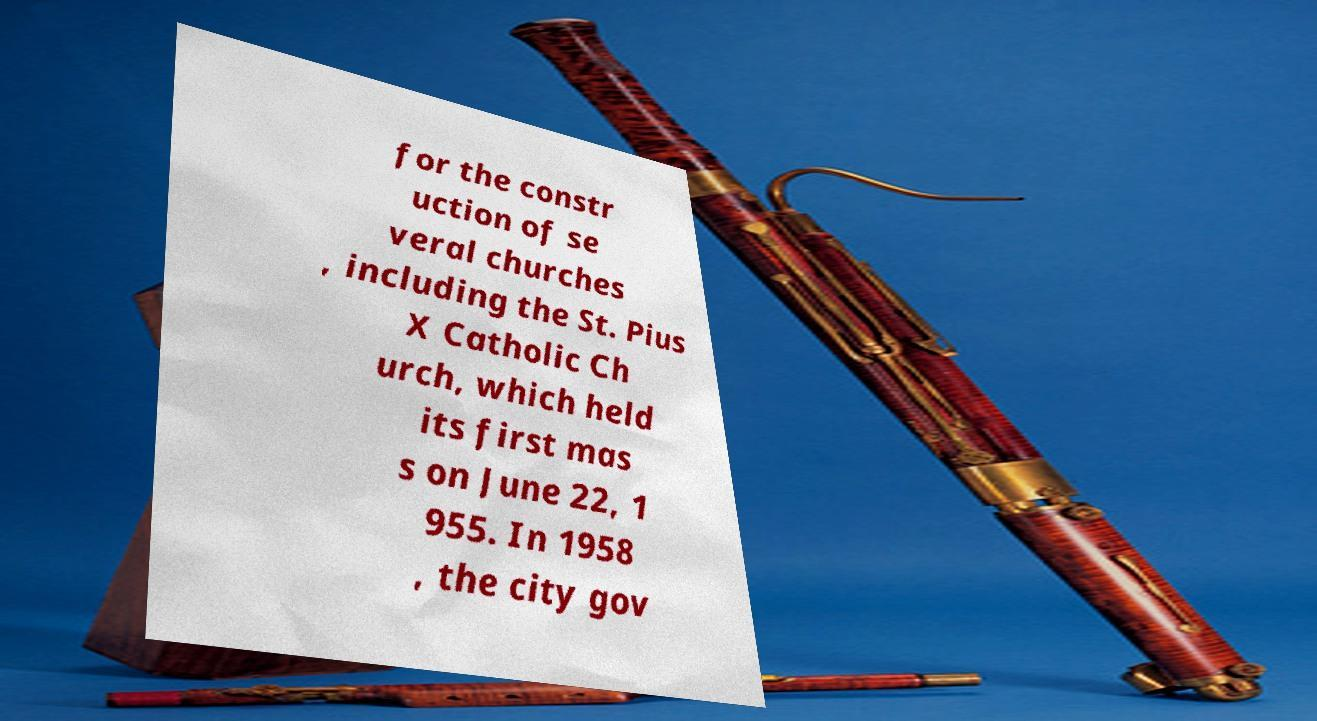Could you extract and type out the text from this image? for the constr uction of se veral churches , including the St. Pius X Catholic Ch urch, which held its first mas s on June 22, 1 955. In 1958 , the city gov 